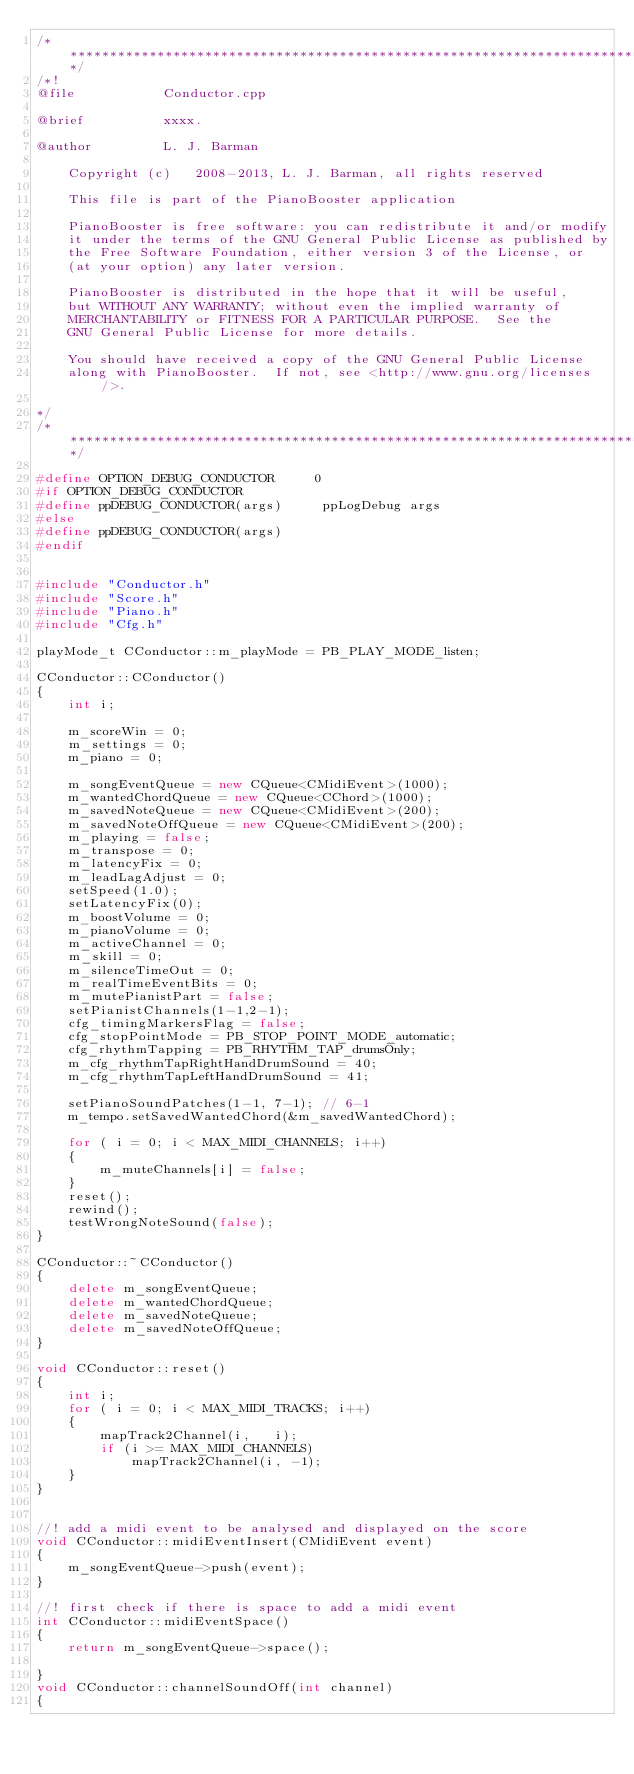<code> <loc_0><loc_0><loc_500><loc_500><_C++_>/*********************************************************************************/
/*!
@file           Conductor.cpp

@brief          xxxx.

@author         L. J. Barman

    Copyright (c)   2008-2013, L. J. Barman, all rights reserved

    This file is part of the PianoBooster application

    PianoBooster is free software: you can redistribute it and/or modify
    it under the terms of the GNU General Public License as published by
    the Free Software Foundation, either version 3 of the License, or
    (at your option) any later version.

    PianoBooster is distributed in the hope that it will be useful,
    but WITHOUT ANY WARRANTY; without even the implied warranty of
    MERCHANTABILITY or FITNESS FOR A PARTICULAR PURPOSE.  See the
    GNU General Public License for more details.

    You should have received a copy of the GNU General Public License
    along with PianoBooster.  If not, see <http://www.gnu.org/licenses/>.

*/
/*********************************************************************************/

#define OPTION_DEBUG_CONDUCTOR     0
#if OPTION_DEBUG_CONDUCTOR
#define ppDEBUG_CONDUCTOR(args)     ppLogDebug args
#else
#define ppDEBUG_CONDUCTOR(args)
#endif


#include "Conductor.h"
#include "Score.h"
#include "Piano.h"
#include "Cfg.h"

playMode_t CConductor::m_playMode = PB_PLAY_MODE_listen;

CConductor::CConductor()
{
    int i;

    m_scoreWin = 0;
    m_settings = 0;
    m_piano = 0;

    m_songEventQueue = new CQueue<CMidiEvent>(1000);
    m_wantedChordQueue = new CQueue<CChord>(1000);
    m_savedNoteQueue = new CQueue<CMidiEvent>(200);
    m_savedNoteOffQueue = new CQueue<CMidiEvent>(200);
    m_playing = false;
    m_transpose = 0;
    m_latencyFix = 0;
    m_leadLagAdjust = 0;
    setSpeed(1.0);
    setLatencyFix(0);
    m_boostVolume = 0;
    m_pianoVolume = 0;
    m_activeChannel = 0;
    m_skill = 0;
    m_silenceTimeOut = 0;
    m_realTimeEventBits = 0;
    m_mutePianistPart = false;
    setPianistChannels(1-1,2-1);
    cfg_timingMarkersFlag = false;
    cfg_stopPointMode = PB_STOP_POINT_MODE_automatic;
    cfg_rhythmTapping = PB_RHYTHM_TAP_drumsOnly;
    m_cfg_rhythmTapRightHandDrumSound = 40;
    m_cfg_rhythmTapLeftHandDrumSound = 41;

    setPianoSoundPatches(1-1, 7-1); // 6-1
    m_tempo.setSavedWantedChord(&m_savedWantedChord);

    for ( i = 0; i < MAX_MIDI_CHANNELS; i++)
    {
        m_muteChannels[i] = false;
    }
    reset();
    rewind();
    testWrongNoteSound(false);
}

CConductor::~CConductor()
{
    delete m_songEventQueue;
    delete m_wantedChordQueue;
    delete m_savedNoteQueue;
    delete m_savedNoteOffQueue;
}

void CConductor::reset()
{
    int i;
    for ( i = 0; i < MAX_MIDI_TRACKS; i++)
    {
        mapTrack2Channel(i,   i);
        if (i >= MAX_MIDI_CHANNELS)
            mapTrack2Channel(i, -1);
    }
}


//! add a midi event to be analysed and displayed on the score
void CConductor::midiEventInsert(CMidiEvent event)
{
    m_songEventQueue->push(event);
}

//! first check if there is space to add a midi event
int CConductor::midiEventSpace()
{
    return m_songEventQueue->space();

}
void CConductor::channelSoundOff(int channel)
{</code> 